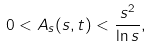<formula> <loc_0><loc_0><loc_500><loc_500>0 < A _ { s } ( s , t ) < \frac { s ^ { 2 } } { \ln s } ,</formula> 